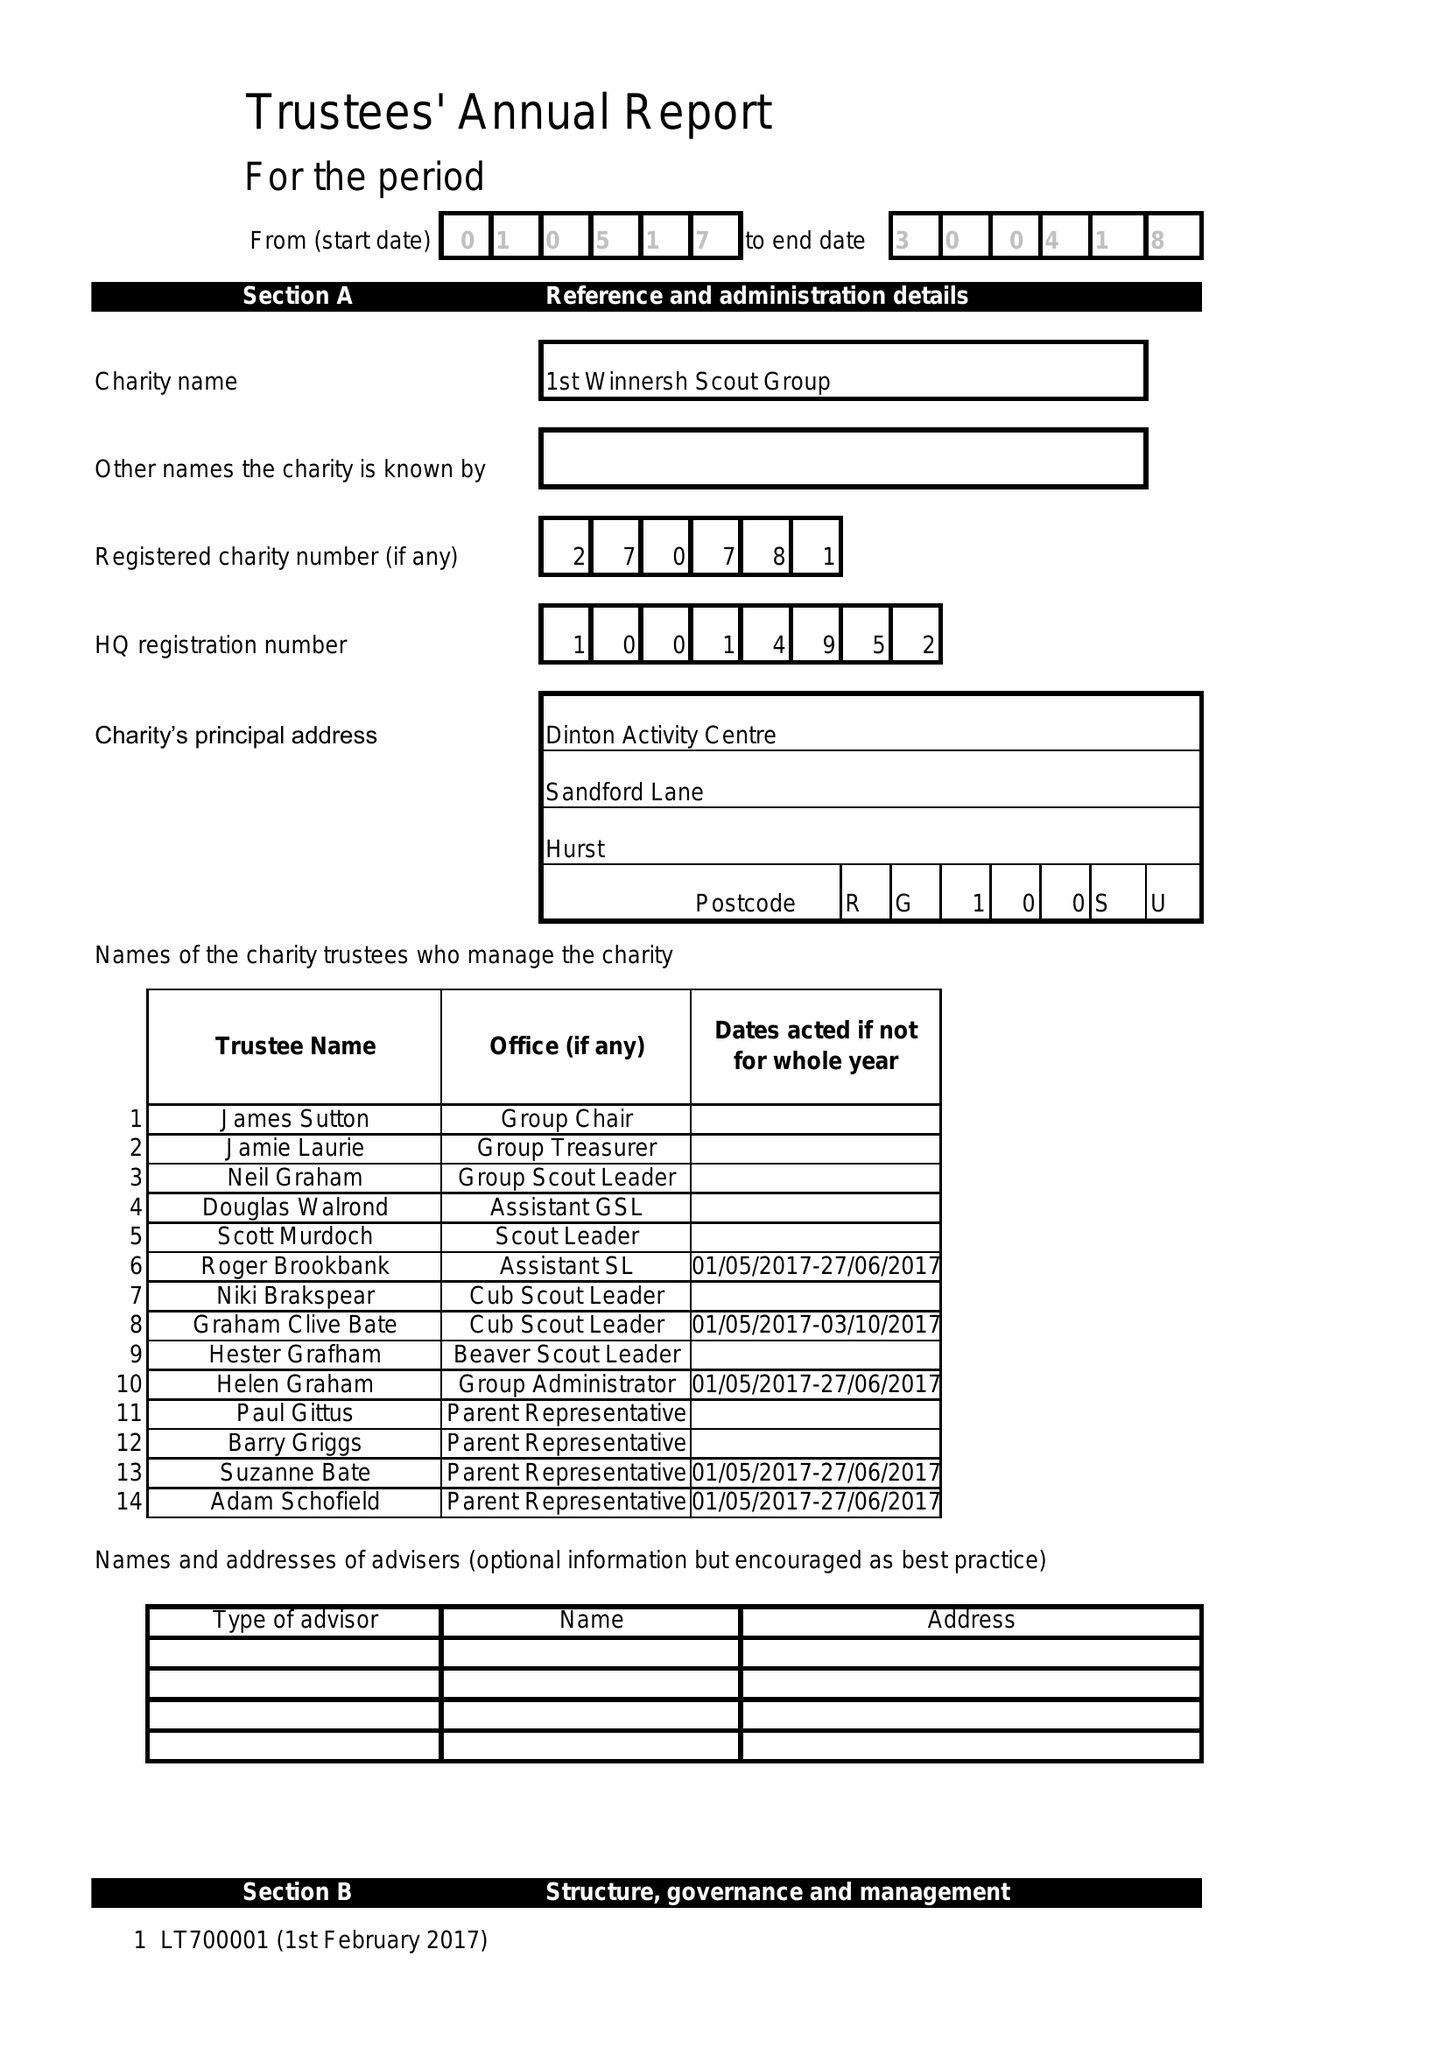What is the value for the address__postcode?
Answer the question using a single word or phrase. RG10 0SU 